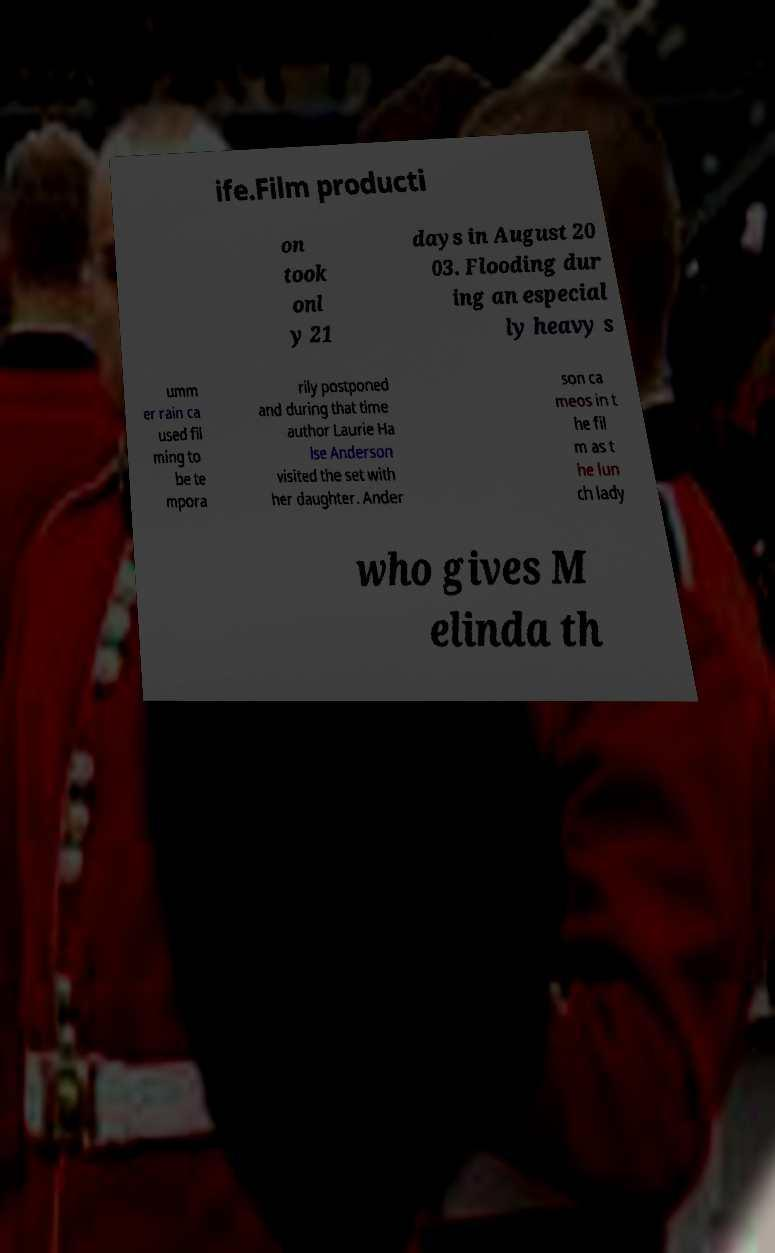I need the written content from this picture converted into text. Can you do that? ife.Film producti on took onl y 21 days in August 20 03. Flooding dur ing an especial ly heavy s umm er rain ca used fil ming to be te mpora rily postponed and during that time author Laurie Ha lse Anderson visited the set with her daughter. Ander son ca meos in t he fil m as t he lun ch lady who gives M elinda th 